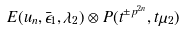Convert formula to latex. <formula><loc_0><loc_0><loc_500><loc_500>E ( u _ { n } , \bar { \epsilon } _ { 1 } , \lambda _ { 2 } ) \otimes P ( t ^ { \pm p ^ { 2 n } } , t \mu _ { 2 } )</formula> 